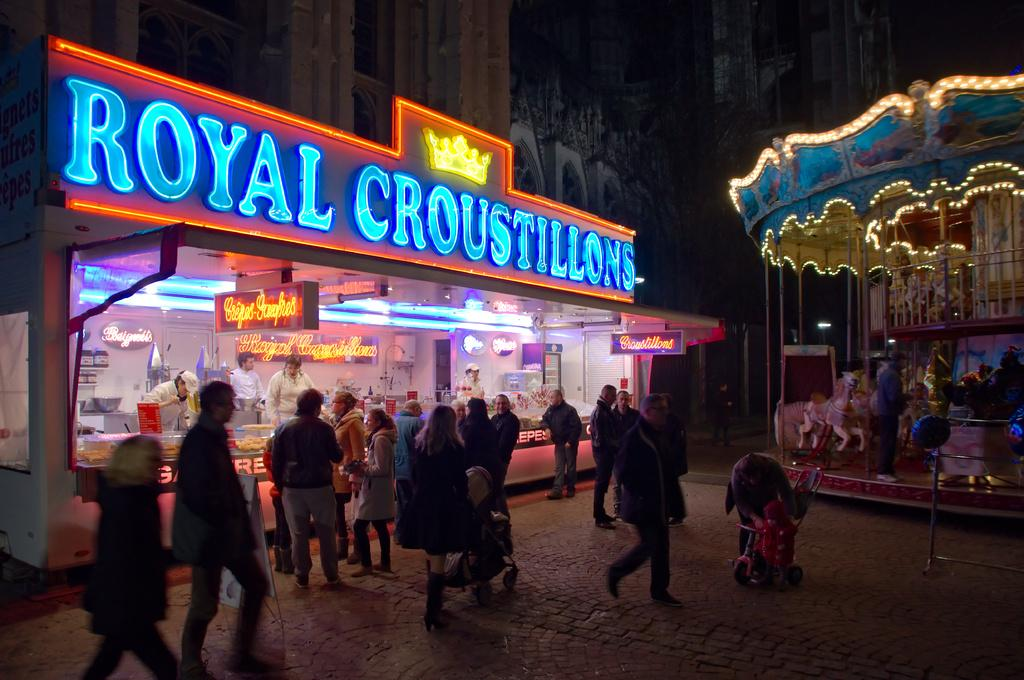Where was the image taken? The image was taken outside. What type of scene is depicted in the image? The scene resembles a circus. What is located in the middle of the image? There is a store in the middle of the image. How many people can be seen in the middle of the image? There are multiple people visible in the middle of the image. What type of activities are available on the right side of the image? There are games visible on the right side of the image. What type of insurance policy is being sold at the store in the image? There is no indication of insurance being sold or discussed in the image; it features a circus scene with a store and games. 